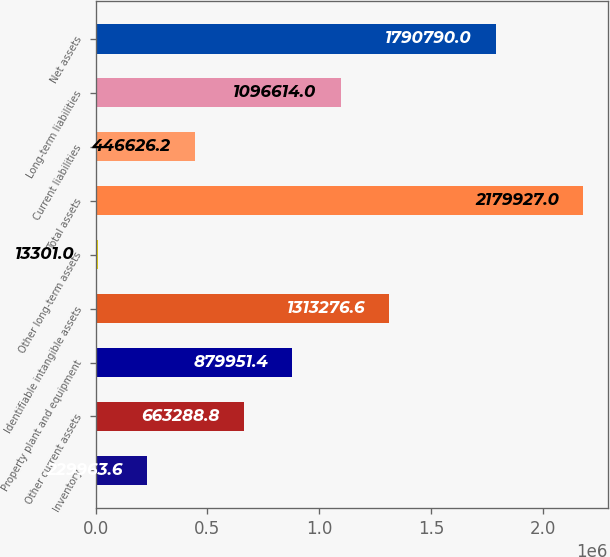<chart> <loc_0><loc_0><loc_500><loc_500><bar_chart><fcel>Inventory<fcel>Other current assets<fcel>Property plant and equipment<fcel>Identifiable intangible assets<fcel>Other long-term assets<fcel>Total assets<fcel>Current liabilities<fcel>Long-term liabilities<fcel>Net assets<nl><fcel>229964<fcel>663289<fcel>879951<fcel>1.31328e+06<fcel>13301<fcel>2.17993e+06<fcel>446626<fcel>1.09661e+06<fcel>1.79079e+06<nl></chart> 